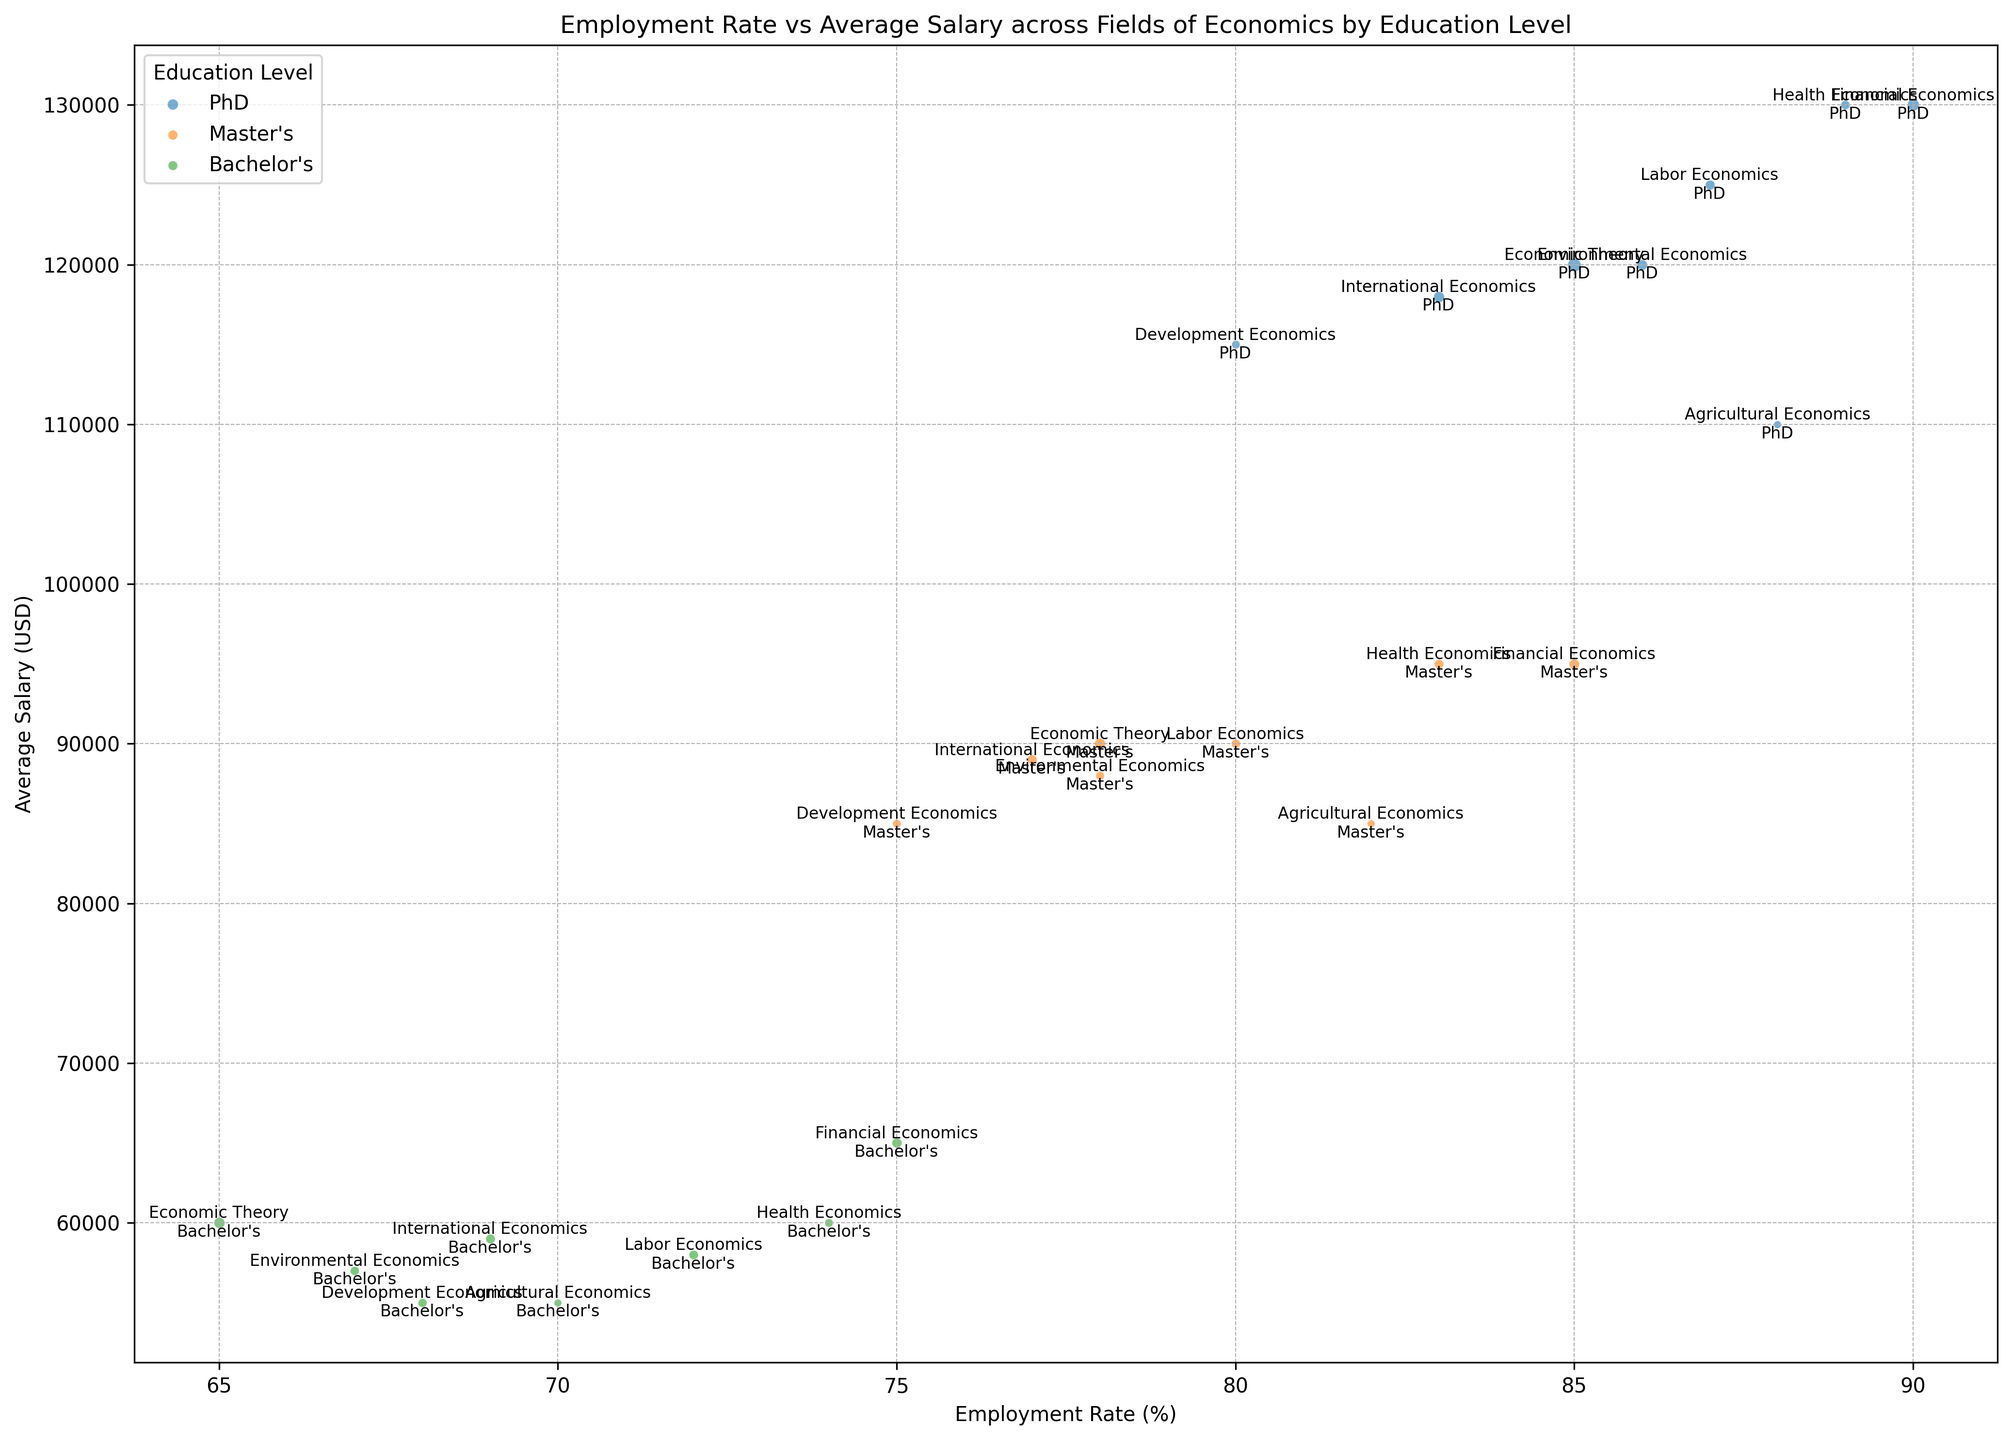Which field has the highest employment rate for PhD graduates? Look at the dots colored for PhD and find the one with the highest position on the Employment Rate axis.
Answer: Financial Economics How does the average salary for Bachelor's degree holders in Health Economics compare to those in Environmental Economics? Compare the y-axis positions of the Bachelor's degree dots labeled Health Economics and Environmental Economics.
Answer: Higher in Health Economics What is the total number of Master's degree graduates in Agricultural Economics and Labor Economics combined? Extract the number of graduates for each field's Master's level, then sum 100 (Agricultural Economics) and 140 (Labor Economics).
Answer: 240 What is the difference in employment rates between Bachelor's and PhD holders in Development Economics? Subtract the employment rate of Bachelor's (68) from that of PhD (80).
Answer: 12% Which Bachelor's degree field shows the lowest average salary? Look at the lowest point on the y-axis among dots labeled with “Bachelor’s.”
Answer: Agricultural Economics Which educational qualification in International Economics has the largest number of graduates? Compare the sizes of the bubbles labeled International Economics.
Answer: Bachelor's Across all fields, which degree level generally has the highest employment rates? Compare the relative positions on the x-axis of dots categorized by degree level.
Answer: PhD Is there any field where the Master's graduates have higher employment rates than PhD graduates in a different field? Identify fields' Master's and compare their dots' x-values with other fields' PhDs.
Answer: No Which field presents the highest average salary for Master’s degree holders? Identify the highest point on the y-axis among dots labeled with “Master’s.”
Answer: Health Economics 